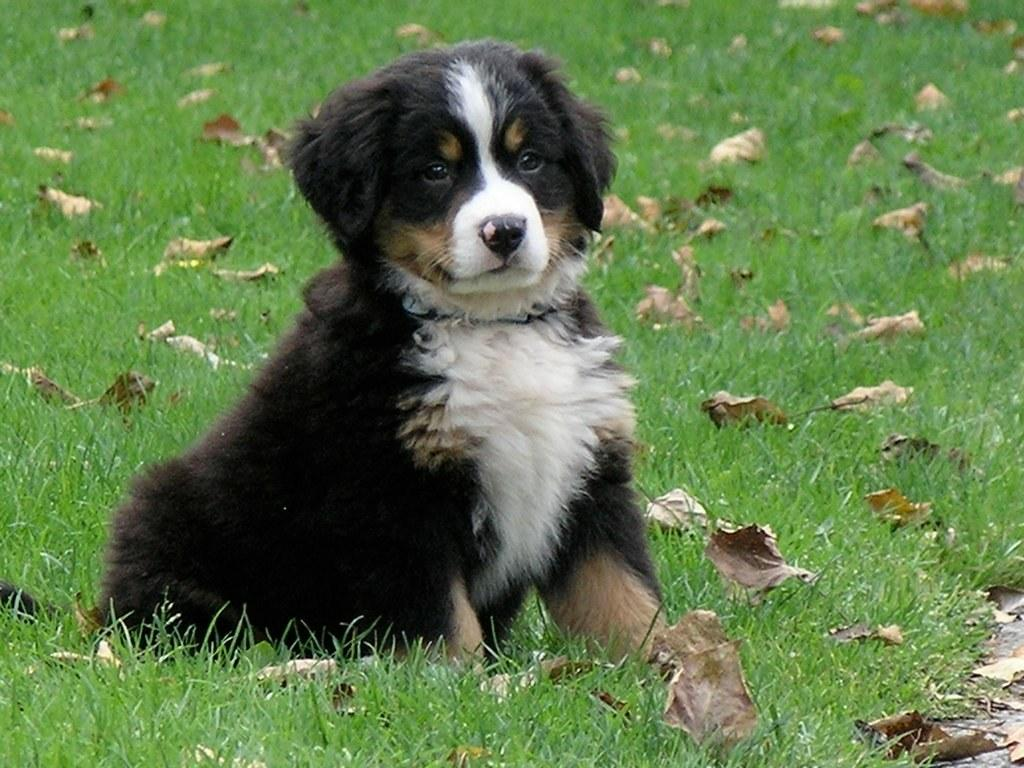What type of animal is in the image? There is a dog in the image. What colors can be seen on the dog? The dog is black and white in color. What type of terrain is visible in the foreground of the image? There is grass in the foreground of the image. What additional elements can be seen in the image? Dry leaves are present in the image. What type of organization is depicted on the roof in the image? There is no roof or organization present in the image; it features a dog and grass with dry leaves. 